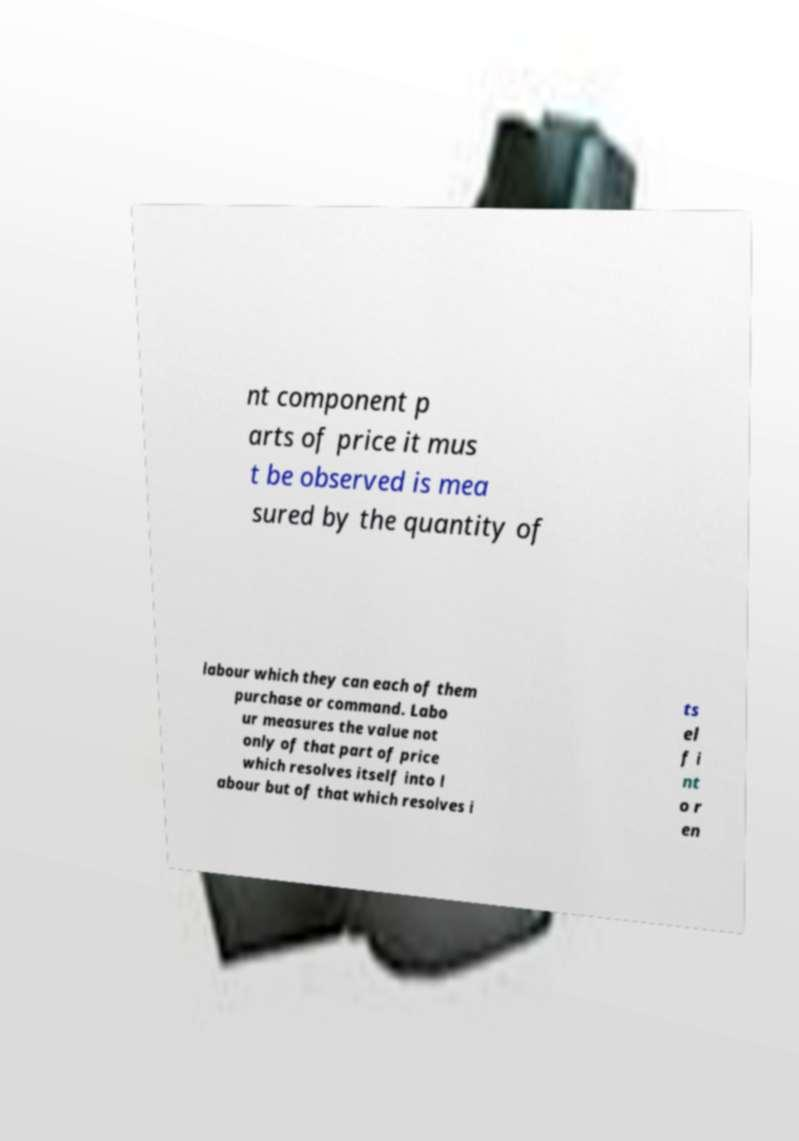There's text embedded in this image that I need extracted. Can you transcribe it verbatim? nt component p arts of price it mus t be observed is mea sured by the quantity of labour which they can each of them purchase or command. Labo ur measures the value not only of that part of price which resolves itself into l abour but of that which resolves i ts el f i nt o r en 